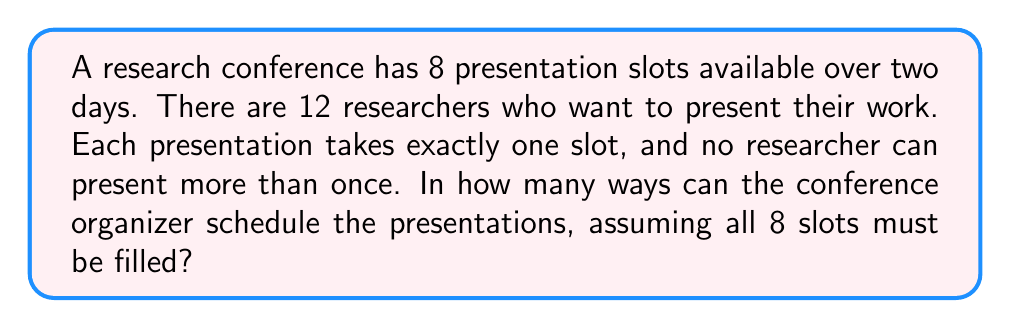Solve this math problem. Let's approach this step-by-step:

1) First, we need to choose 8 researchers out of 12 to present. This is a combination problem, denoted as $\binom{12}{8}$ or $C(12,8)$.

2) The number of ways to choose 8 researchers out of 12 is:

   $$\binom{12}{8} = \frac{12!}{8!(12-8)!} = \frac{12!}{8!4!}$$

3) Now, for each selection of 8 researchers, we need to arrange them in the 8 available slots. This is a permutation of 8 items, which is simply 8!.

4) By the multiplication principle, the total number of ways to schedule the presentations is the product of the number of ways to select 8 researchers and the number of ways to arrange them:

   $$\binom{12}{8} \times 8!$$

5) Let's calculate this:
   
   $$\frac{12!}{8!4!} \times 8! = \frac{12!}{4!}$$

6) Expanding this:
   
   $$\frac{12 \times 11 \times 10 \times 9 \times 8!}{4 \times 3 \times 2 \times 1} = 11,880 \times 330 = 3,920,400$$

Therefore, there are 3,920,400 unique ways to schedule the conference presentations.
Answer: 3,920,400 